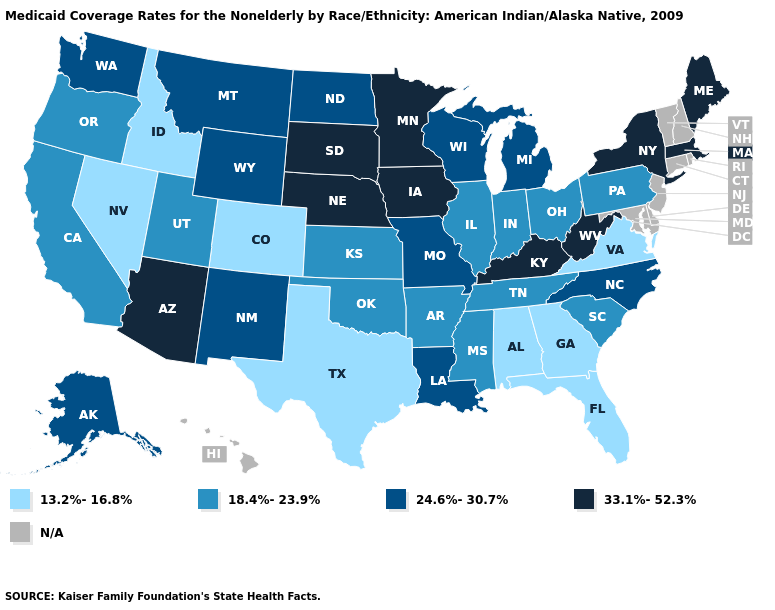What is the value of Arkansas?
Be succinct. 18.4%-23.9%. Name the states that have a value in the range 24.6%-30.7%?
Give a very brief answer. Alaska, Louisiana, Michigan, Missouri, Montana, New Mexico, North Carolina, North Dakota, Washington, Wisconsin, Wyoming. Which states have the highest value in the USA?
Be succinct. Arizona, Iowa, Kentucky, Maine, Massachusetts, Minnesota, Nebraska, New York, South Dakota, West Virginia. What is the highest value in states that border Connecticut?
Answer briefly. 33.1%-52.3%. Name the states that have a value in the range 24.6%-30.7%?
Give a very brief answer. Alaska, Louisiana, Michigan, Missouri, Montana, New Mexico, North Carolina, North Dakota, Washington, Wisconsin, Wyoming. Is the legend a continuous bar?
Keep it brief. No. Is the legend a continuous bar?
Answer briefly. No. What is the highest value in the USA?
Be succinct. 33.1%-52.3%. Among the states that border Missouri , which have the highest value?
Write a very short answer. Iowa, Kentucky, Nebraska. How many symbols are there in the legend?
Answer briefly. 5. What is the lowest value in the USA?
Be succinct. 13.2%-16.8%. What is the value of Arkansas?
Answer briefly. 18.4%-23.9%. What is the lowest value in the West?
Give a very brief answer. 13.2%-16.8%. Which states have the lowest value in the Northeast?
Write a very short answer. Pennsylvania. What is the value of Ohio?
Be succinct. 18.4%-23.9%. 